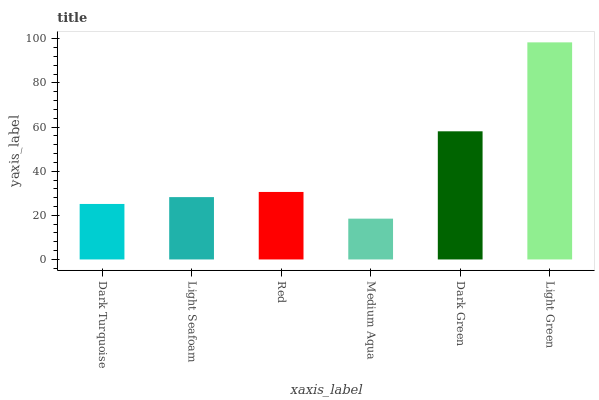Is Medium Aqua the minimum?
Answer yes or no. Yes. Is Light Green the maximum?
Answer yes or no. Yes. Is Light Seafoam the minimum?
Answer yes or no. No. Is Light Seafoam the maximum?
Answer yes or no. No. Is Light Seafoam greater than Dark Turquoise?
Answer yes or no. Yes. Is Dark Turquoise less than Light Seafoam?
Answer yes or no. Yes. Is Dark Turquoise greater than Light Seafoam?
Answer yes or no. No. Is Light Seafoam less than Dark Turquoise?
Answer yes or no. No. Is Red the high median?
Answer yes or no. Yes. Is Light Seafoam the low median?
Answer yes or no. Yes. Is Dark Turquoise the high median?
Answer yes or no. No. Is Light Green the low median?
Answer yes or no. No. 